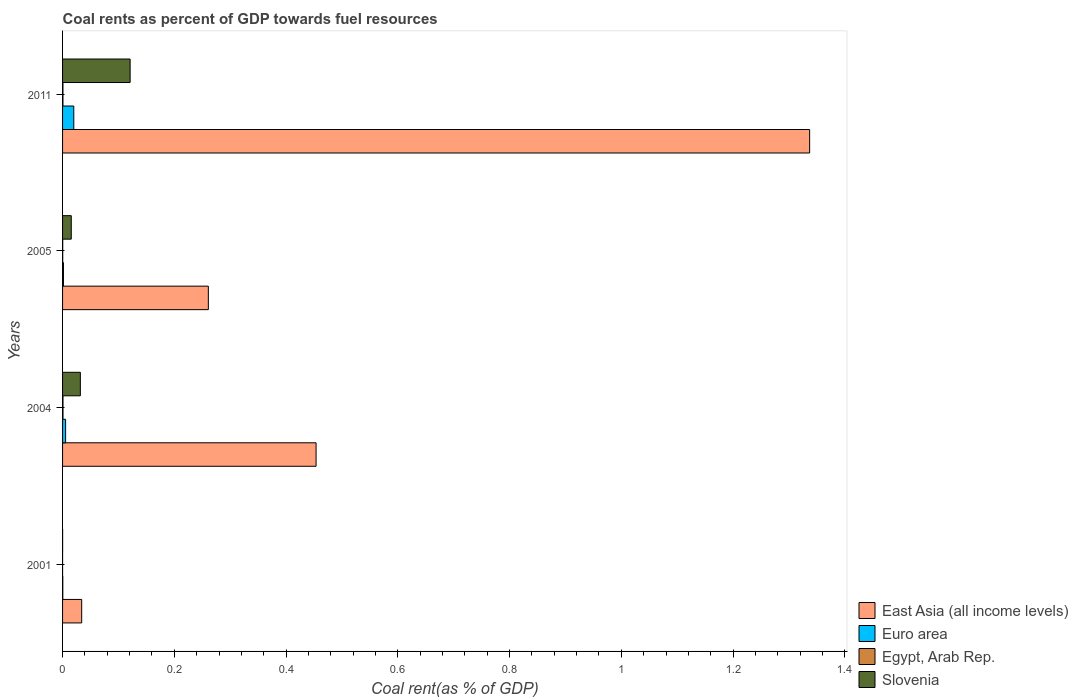Are the number of bars per tick equal to the number of legend labels?
Make the answer very short. Yes. Are the number of bars on each tick of the Y-axis equal?
Your answer should be very brief. Yes. What is the label of the 3rd group of bars from the top?
Keep it short and to the point. 2004. What is the coal rent in Egypt, Arab Rep. in 2001?
Make the answer very short. 1.02739128441411e-6. Across all years, what is the maximum coal rent in Euro area?
Your response must be concise. 0.02. Across all years, what is the minimum coal rent in Euro area?
Your answer should be compact. 0. In which year was the coal rent in Slovenia minimum?
Your answer should be compact. 2001. What is the total coal rent in Slovenia in the graph?
Make the answer very short. 0.17. What is the difference between the coal rent in Euro area in 2004 and that in 2011?
Provide a succinct answer. -0.01. What is the difference between the coal rent in Euro area in 2004 and the coal rent in East Asia (all income levels) in 2001?
Ensure brevity in your answer.  -0.03. What is the average coal rent in Euro area per year?
Give a very brief answer. 0.01. In the year 2004, what is the difference between the coal rent in Euro area and coal rent in Egypt, Arab Rep.?
Keep it short and to the point. 0. In how many years, is the coal rent in East Asia (all income levels) greater than 0.8400000000000001 %?
Make the answer very short. 1. What is the ratio of the coal rent in Euro area in 2004 to that in 2011?
Provide a succinct answer. 0.27. Is the difference between the coal rent in Euro area in 2001 and 2011 greater than the difference between the coal rent in Egypt, Arab Rep. in 2001 and 2011?
Your response must be concise. No. What is the difference between the highest and the second highest coal rent in Euro area?
Keep it short and to the point. 0.01. What is the difference between the highest and the lowest coal rent in East Asia (all income levels)?
Provide a short and direct response. 1.3. In how many years, is the coal rent in Euro area greater than the average coal rent in Euro area taken over all years?
Your response must be concise. 1. Is it the case that in every year, the sum of the coal rent in Slovenia and coal rent in Euro area is greater than the sum of coal rent in Egypt, Arab Rep. and coal rent in East Asia (all income levels)?
Offer a terse response. No. What does the 2nd bar from the top in 2004 represents?
Offer a terse response. Egypt, Arab Rep. What does the 4th bar from the bottom in 2004 represents?
Your response must be concise. Slovenia. Is it the case that in every year, the sum of the coal rent in East Asia (all income levels) and coal rent in Egypt, Arab Rep. is greater than the coal rent in Euro area?
Ensure brevity in your answer.  Yes. How many bars are there?
Offer a very short reply. 16. What is the difference between two consecutive major ticks on the X-axis?
Make the answer very short. 0.2. Are the values on the major ticks of X-axis written in scientific E-notation?
Keep it short and to the point. No. Does the graph contain any zero values?
Keep it short and to the point. No. Does the graph contain grids?
Offer a terse response. No. How many legend labels are there?
Your answer should be compact. 4. How are the legend labels stacked?
Provide a succinct answer. Vertical. What is the title of the graph?
Provide a short and direct response. Coal rents as percent of GDP towards fuel resources. What is the label or title of the X-axis?
Ensure brevity in your answer.  Coal rent(as % of GDP). What is the Coal rent(as % of GDP) of East Asia (all income levels) in 2001?
Make the answer very short. 0.03. What is the Coal rent(as % of GDP) of Euro area in 2001?
Your response must be concise. 0. What is the Coal rent(as % of GDP) of Egypt, Arab Rep. in 2001?
Provide a succinct answer. 1.02739128441411e-6. What is the Coal rent(as % of GDP) of Slovenia in 2001?
Offer a very short reply. 8.55127305686454e-5. What is the Coal rent(as % of GDP) of East Asia (all income levels) in 2004?
Provide a succinct answer. 0.45. What is the Coal rent(as % of GDP) in Euro area in 2004?
Make the answer very short. 0.01. What is the Coal rent(as % of GDP) in Egypt, Arab Rep. in 2004?
Your answer should be very brief. 0. What is the Coal rent(as % of GDP) of Slovenia in 2004?
Provide a succinct answer. 0.03. What is the Coal rent(as % of GDP) in East Asia (all income levels) in 2005?
Keep it short and to the point. 0.26. What is the Coal rent(as % of GDP) in Euro area in 2005?
Offer a very short reply. 0. What is the Coal rent(as % of GDP) in Egypt, Arab Rep. in 2005?
Provide a succinct answer. 0. What is the Coal rent(as % of GDP) of Slovenia in 2005?
Provide a short and direct response. 0.02. What is the Coal rent(as % of GDP) in East Asia (all income levels) in 2011?
Your answer should be compact. 1.34. What is the Coal rent(as % of GDP) of Euro area in 2011?
Your response must be concise. 0.02. What is the Coal rent(as % of GDP) of Egypt, Arab Rep. in 2011?
Give a very brief answer. 0. What is the Coal rent(as % of GDP) of Slovenia in 2011?
Give a very brief answer. 0.12. Across all years, what is the maximum Coal rent(as % of GDP) of East Asia (all income levels)?
Your response must be concise. 1.34. Across all years, what is the maximum Coal rent(as % of GDP) in Euro area?
Offer a very short reply. 0.02. Across all years, what is the maximum Coal rent(as % of GDP) in Egypt, Arab Rep.?
Make the answer very short. 0. Across all years, what is the maximum Coal rent(as % of GDP) of Slovenia?
Keep it short and to the point. 0.12. Across all years, what is the minimum Coal rent(as % of GDP) in East Asia (all income levels)?
Your response must be concise. 0.03. Across all years, what is the minimum Coal rent(as % of GDP) in Euro area?
Offer a very short reply. 0. Across all years, what is the minimum Coal rent(as % of GDP) in Egypt, Arab Rep.?
Make the answer very short. 1.02739128441411e-6. Across all years, what is the minimum Coal rent(as % of GDP) in Slovenia?
Keep it short and to the point. 8.55127305686454e-5. What is the total Coal rent(as % of GDP) of East Asia (all income levels) in the graph?
Your answer should be very brief. 2.09. What is the total Coal rent(as % of GDP) in Euro area in the graph?
Your answer should be very brief. 0.03. What is the total Coal rent(as % of GDP) of Egypt, Arab Rep. in the graph?
Offer a very short reply. 0. What is the total Coal rent(as % of GDP) of Slovenia in the graph?
Your answer should be very brief. 0.17. What is the difference between the Coal rent(as % of GDP) of East Asia (all income levels) in 2001 and that in 2004?
Your answer should be compact. -0.42. What is the difference between the Coal rent(as % of GDP) of Euro area in 2001 and that in 2004?
Provide a short and direct response. -0.01. What is the difference between the Coal rent(as % of GDP) of Egypt, Arab Rep. in 2001 and that in 2004?
Make the answer very short. -0. What is the difference between the Coal rent(as % of GDP) in Slovenia in 2001 and that in 2004?
Your answer should be very brief. -0.03. What is the difference between the Coal rent(as % of GDP) of East Asia (all income levels) in 2001 and that in 2005?
Your answer should be compact. -0.23. What is the difference between the Coal rent(as % of GDP) in Euro area in 2001 and that in 2005?
Offer a very short reply. -0. What is the difference between the Coal rent(as % of GDP) of Egypt, Arab Rep. in 2001 and that in 2005?
Provide a succinct answer. -0. What is the difference between the Coal rent(as % of GDP) of Slovenia in 2001 and that in 2005?
Your answer should be compact. -0.02. What is the difference between the Coal rent(as % of GDP) of East Asia (all income levels) in 2001 and that in 2011?
Make the answer very short. -1.3. What is the difference between the Coal rent(as % of GDP) of Euro area in 2001 and that in 2011?
Make the answer very short. -0.02. What is the difference between the Coal rent(as % of GDP) in Egypt, Arab Rep. in 2001 and that in 2011?
Ensure brevity in your answer.  -0. What is the difference between the Coal rent(as % of GDP) in Slovenia in 2001 and that in 2011?
Your answer should be very brief. -0.12. What is the difference between the Coal rent(as % of GDP) of East Asia (all income levels) in 2004 and that in 2005?
Provide a short and direct response. 0.19. What is the difference between the Coal rent(as % of GDP) of Euro area in 2004 and that in 2005?
Give a very brief answer. 0. What is the difference between the Coal rent(as % of GDP) in Egypt, Arab Rep. in 2004 and that in 2005?
Your answer should be compact. 0. What is the difference between the Coal rent(as % of GDP) of Slovenia in 2004 and that in 2005?
Your answer should be very brief. 0.02. What is the difference between the Coal rent(as % of GDP) in East Asia (all income levels) in 2004 and that in 2011?
Your answer should be very brief. -0.88. What is the difference between the Coal rent(as % of GDP) of Euro area in 2004 and that in 2011?
Your response must be concise. -0.01. What is the difference between the Coal rent(as % of GDP) in Egypt, Arab Rep. in 2004 and that in 2011?
Make the answer very short. 0. What is the difference between the Coal rent(as % of GDP) in Slovenia in 2004 and that in 2011?
Your answer should be very brief. -0.09. What is the difference between the Coal rent(as % of GDP) of East Asia (all income levels) in 2005 and that in 2011?
Keep it short and to the point. -1.08. What is the difference between the Coal rent(as % of GDP) of Euro area in 2005 and that in 2011?
Your response must be concise. -0.02. What is the difference between the Coal rent(as % of GDP) in Egypt, Arab Rep. in 2005 and that in 2011?
Make the answer very short. -0. What is the difference between the Coal rent(as % of GDP) in Slovenia in 2005 and that in 2011?
Offer a terse response. -0.11. What is the difference between the Coal rent(as % of GDP) in East Asia (all income levels) in 2001 and the Coal rent(as % of GDP) in Euro area in 2004?
Your answer should be compact. 0.03. What is the difference between the Coal rent(as % of GDP) in East Asia (all income levels) in 2001 and the Coal rent(as % of GDP) in Egypt, Arab Rep. in 2004?
Ensure brevity in your answer.  0.03. What is the difference between the Coal rent(as % of GDP) of East Asia (all income levels) in 2001 and the Coal rent(as % of GDP) of Slovenia in 2004?
Provide a short and direct response. 0. What is the difference between the Coal rent(as % of GDP) in Euro area in 2001 and the Coal rent(as % of GDP) in Egypt, Arab Rep. in 2004?
Keep it short and to the point. -0. What is the difference between the Coal rent(as % of GDP) of Euro area in 2001 and the Coal rent(as % of GDP) of Slovenia in 2004?
Provide a short and direct response. -0.03. What is the difference between the Coal rent(as % of GDP) in Egypt, Arab Rep. in 2001 and the Coal rent(as % of GDP) in Slovenia in 2004?
Give a very brief answer. -0.03. What is the difference between the Coal rent(as % of GDP) in East Asia (all income levels) in 2001 and the Coal rent(as % of GDP) in Euro area in 2005?
Provide a succinct answer. 0.03. What is the difference between the Coal rent(as % of GDP) in East Asia (all income levels) in 2001 and the Coal rent(as % of GDP) in Egypt, Arab Rep. in 2005?
Your response must be concise. 0.03. What is the difference between the Coal rent(as % of GDP) in East Asia (all income levels) in 2001 and the Coal rent(as % of GDP) in Slovenia in 2005?
Offer a very short reply. 0.02. What is the difference between the Coal rent(as % of GDP) in Euro area in 2001 and the Coal rent(as % of GDP) in Slovenia in 2005?
Offer a very short reply. -0.02. What is the difference between the Coal rent(as % of GDP) of Egypt, Arab Rep. in 2001 and the Coal rent(as % of GDP) of Slovenia in 2005?
Keep it short and to the point. -0.02. What is the difference between the Coal rent(as % of GDP) in East Asia (all income levels) in 2001 and the Coal rent(as % of GDP) in Euro area in 2011?
Your answer should be very brief. 0.01. What is the difference between the Coal rent(as % of GDP) of East Asia (all income levels) in 2001 and the Coal rent(as % of GDP) of Egypt, Arab Rep. in 2011?
Keep it short and to the point. 0.03. What is the difference between the Coal rent(as % of GDP) of East Asia (all income levels) in 2001 and the Coal rent(as % of GDP) of Slovenia in 2011?
Your answer should be very brief. -0.09. What is the difference between the Coal rent(as % of GDP) in Euro area in 2001 and the Coal rent(as % of GDP) in Egypt, Arab Rep. in 2011?
Offer a terse response. -0. What is the difference between the Coal rent(as % of GDP) in Euro area in 2001 and the Coal rent(as % of GDP) in Slovenia in 2011?
Your answer should be very brief. -0.12. What is the difference between the Coal rent(as % of GDP) of Egypt, Arab Rep. in 2001 and the Coal rent(as % of GDP) of Slovenia in 2011?
Offer a very short reply. -0.12. What is the difference between the Coal rent(as % of GDP) of East Asia (all income levels) in 2004 and the Coal rent(as % of GDP) of Euro area in 2005?
Provide a succinct answer. 0.45. What is the difference between the Coal rent(as % of GDP) of East Asia (all income levels) in 2004 and the Coal rent(as % of GDP) of Egypt, Arab Rep. in 2005?
Offer a very short reply. 0.45. What is the difference between the Coal rent(as % of GDP) of East Asia (all income levels) in 2004 and the Coal rent(as % of GDP) of Slovenia in 2005?
Provide a short and direct response. 0.44. What is the difference between the Coal rent(as % of GDP) of Euro area in 2004 and the Coal rent(as % of GDP) of Egypt, Arab Rep. in 2005?
Your answer should be compact. 0.01. What is the difference between the Coal rent(as % of GDP) in Euro area in 2004 and the Coal rent(as % of GDP) in Slovenia in 2005?
Provide a succinct answer. -0.01. What is the difference between the Coal rent(as % of GDP) in Egypt, Arab Rep. in 2004 and the Coal rent(as % of GDP) in Slovenia in 2005?
Your response must be concise. -0.01. What is the difference between the Coal rent(as % of GDP) in East Asia (all income levels) in 2004 and the Coal rent(as % of GDP) in Euro area in 2011?
Make the answer very short. 0.43. What is the difference between the Coal rent(as % of GDP) of East Asia (all income levels) in 2004 and the Coal rent(as % of GDP) of Egypt, Arab Rep. in 2011?
Your answer should be compact. 0.45. What is the difference between the Coal rent(as % of GDP) in East Asia (all income levels) in 2004 and the Coal rent(as % of GDP) in Slovenia in 2011?
Your response must be concise. 0.33. What is the difference between the Coal rent(as % of GDP) of Euro area in 2004 and the Coal rent(as % of GDP) of Egypt, Arab Rep. in 2011?
Your answer should be very brief. 0. What is the difference between the Coal rent(as % of GDP) in Euro area in 2004 and the Coal rent(as % of GDP) in Slovenia in 2011?
Give a very brief answer. -0.12. What is the difference between the Coal rent(as % of GDP) of Egypt, Arab Rep. in 2004 and the Coal rent(as % of GDP) of Slovenia in 2011?
Your response must be concise. -0.12. What is the difference between the Coal rent(as % of GDP) of East Asia (all income levels) in 2005 and the Coal rent(as % of GDP) of Euro area in 2011?
Offer a terse response. 0.24. What is the difference between the Coal rent(as % of GDP) in East Asia (all income levels) in 2005 and the Coal rent(as % of GDP) in Egypt, Arab Rep. in 2011?
Provide a short and direct response. 0.26. What is the difference between the Coal rent(as % of GDP) in East Asia (all income levels) in 2005 and the Coal rent(as % of GDP) in Slovenia in 2011?
Your answer should be very brief. 0.14. What is the difference between the Coal rent(as % of GDP) in Euro area in 2005 and the Coal rent(as % of GDP) in Egypt, Arab Rep. in 2011?
Make the answer very short. 0. What is the difference between the Coal rent(as % of GDP) of Euro area in 2005 and the Coal rent(as % of GDP) of Slovenia in 2011?
Keep it short and to the point. -0.12. What is the difference between the Coal rent(as % of GDP) in Egypt, Arab Rep. in 2005 and the Coal rent(as % of GDP) in Slovenia in 2011?
Provide a succinct answer. -0.12. What is the average Coal rent(as % of GDP) of East Asia (all income levels) per year?
Give a very brief answer. 0.52. What is the average Coal rent(as % of GDP) in Euro area per year?
Keep it short and to the point. 0.01. What is the average Coal rent(as % of GDP) in Slovenia per year?
Give a very brief answer. 0.04. In the year 2001, what is the difference between the Coal rent(as % of GDP) in East Asia (all income levels) and Coal rent(as % of GDP) in Euro area?
Your response must be concise. 0.03. In the year 2001, what is the difference between the Coal rent(as % of GDP) in East Asia (all income levels) and Coal rent(as % of GDP) in Egypt, Arab Rep.?
Your response must be concise. 0.03. In the year 2001, what is the difference between the Coal rent(as % of GDP) in East Asia (all income levels) and Coal rent(as % of GDP) in Slovenia?
Your answer should be compact. 0.03. In the year 2001, what is the difference between the Coal rent(as % of GDP) of Euro area and Coal rent(as % of GDP) of Egypt, Arab Rep.?
Ensure brevity in your answer.  0. In the year 2001, what is the difference between the Coal rent(as % of GDP) in Euro area and Coal rent(as % of GDP) in Slovenia?
Make the answer very short. 0. In the year 2001, what is the difference between the Coal rent(as % of GDP) in Egypt, Arab Rep. and Coal rent(as % of GDP) in Slovenia?
Ensure brevity in your answer.  -0. In the year 2004, what is the difference between the Coal rent(as % of GDP) in East Asia (all income levels) and Coal rent(as % of GDP) in Euro area?
Your response must be concise. 0.45. In the year 2004, what is the difference between the Coal rent(as % of GDP) of East Asia (all income levels) and Coal rent(as % of GDP) of Egypt, Arab Rep.?
Provide a short and direct response. 0.45. In the year 2004, what is the difference between the Coal rent(as % of GDP) in East Asia (all income levels) and Coal rent(as % of GDP) in Slovenia?
Provide a short and direct response. 0.42. In the year 2004, what is the difference between the Coal rent(as % of GDP) in Euro area and Coal rent(as % of GDP) in Egypt, Arab Rep.?
Ensure brevity in your answer.  0. In the year 2004, what is the difference between the Coal rent(as % of GDP) of Euro area and Coal rent(as % of GDP) of Slovenia?
Your answer should be very brief. -0.03. In the year 2004, what is the difference between the Coal rent(as % of GDP) in Egypt, Arab Rep. and Coal rent(as % of GDP) in Slovenia?
Your response must be concise. -0.03. In the year 2005, what is the difference between the Coal rent(as % of GDP) in East Asia (all income levels) and Coal rent(as % of GDP) in Euro area?
Offer a very short reply. 0.26. In the year 2005, what is the difference between the Coal rent(as % of GDP) of East Asia (all income levels) and Coal rent(as % of GDP) of Egypt, Arab Rep.?
Your answer should be compact. 0.26. In the year 2005, what is the difference between the Coal rent(as % of GDP) of East Asia (all income levels) and Coal rent(as % of GDP) of Slovenia?
Provide a short and direct response. 0.25. In the year 2005, what is the difference between the Coal rent(as % of GDP) in Euro area and Coal rent(as % of GDP) in Egypt, Arab Rep.?
Offer a terse response. 0. In the year 2005, what is the difference between the Coal rent(as % of GDP) of Euro area and Coal rent(as % of GDP) of Slovenia?
Give a very brief answer. -0.01. In the year 2005, what is the difference between the Coal rent(as % of GDP) in Egypt, Arab Rep. and Coal rent(as % of GDP) in Slovenia?
Offer a terse response. -0.02. In the year 2011, what is the difference between the Coal rent(as % of GDP) in East Asia (all income levels) and Coal rent(as % of GDP) in Euro area?
Provide a short and direct response. 1.32. In the year 2011, what is the difference between the Coal rent(as % of GDP) of East Asia (all income levels) and Coal rent(as % of GDP) of Egypt, Arab Rep.?
Ensure brevity in your answer.  1.34. In the year 2011, what is the difference between the Coal rent(as % of GDP) of East Asia (all income levels) and Coal rent(as % of GDP) of Slovenia?
Your answer should be compact. 1.22. In the year 2011, what is the difference between the Coal rent(as % of GDP) of Euro area and Coal rent(as % of GDP) of Egypt, Arab Rep.?
Your answer should be compact. 0.02. In the year 2011, what is the difference between the Coal rent(as % of GDP) in Euro area and Coal rent(as % of GDP) in Slovenia?
Ensure brevity in your answer.  -0.1. In the year 2011, what is the difference between the Coal rent(as % of GDP) in Egypt, Arab Rep. and Coal rent(as % of GDP) in Slovenia?
Make the answer very short. -0.12. What is the ratio of the Coal rent(as % of GDP) in East Asia (all income levels) in 2001 to that in 2004?
Provide a succinct answer. 0.08. What is the ratio of the Coal rent(as % of GDP) in Euro area in 2001 to that in 2004?
Provide a short and direct response. 0.08. What is the ratio of the Coal rent(as % of GDP) in Egypt, Arab Rep. in 2001 to that in 2004?
Offer a very short reply. 0. What is the ratio of the Coal rent(as % of GDP) of Slovenia in 2001 to that in 2004?
Your answer should be very brief. 0. What is the ratio of the Coal rent(as % of GDP) in East Asia (all income levels) in 2001 to that in 2005?
Ensure brevity in your answer.  0.13. What is the ratio of the Coal rent(as % of GDP) of Euro area in 2001 to that in 2005?
Give a very brief answer. 0.27. What is the ratio of the Coal rent(as % of GDP) of Egypt, Arab Rep. in 2001 to that in 2005?
Keep it short and to the point. 0. What is the ratio of the Coal rent(as % of GDP) of Slovenia in 2001 to that in 2005?
Make the answer very short. 0.01. What is the ratio of the Coal rent(as % of GDP) of East Asia (all income levels) in 2001 to that in 2011?
Ensure brevity in your answer.  0.03. What is the ratio of the Coal rent(as % of GDP) of Euro area in 2001 to that in 2011?
Ensure brevity in your answer.  0.02. What is the ratio of the Coal rent(as % of GDP) of Egypt, Arab Rep. in 2001 to that in 2011?
Your answer should be compact. 0. What is the ratio of the Coal rent(as % of GDP) of Slovenia in 2001 to that in 2011?
Offer a very short reply. 0. What is the ratio of the Coal rent(as % of GDP) in East Asia (all income levels) in 2004 to that in 2005?
Your answer should be compact. 1.74. What is the ratio of the Coal rent(as % of GDP) of Euro area in 2004 to that in 2005?
Your answer should be very brief. 3.44. What is the ratio of the Coal rent(as % of GDP) in Egypt, Arab Rep. in 2004 to that in 2005?
Offer a very short reply. 2.83. What is the ratio of the Coal rent(as % of GDP) in Slovenia in 2004 to that in 2005?
Your answer should be very brief. 2.04. What is the ratio of the Coal rent(as % of GDP) of East Asia (all income levels) in 2004 to that in 2011?
Provide a succinct answer. 0.34. What is the ratio of the Coal rent(as % of GDP) in Euro area in 2004 to that in 2011?
Offer a terse response. 0.27. What is the ratio of the Coal rent(as % of GDP) of Egypt, Arab Rep. in 2004 to that in 2011?
Ensure brevity in your answer.  1.13. What is the ratio of the Coal rent(as % of GDP) of Slovenia in 2004 to that in 2011?
Make the answer very short. 0.26. What is the ratio of the Coal rent(as % of GDP) of East Asia (all income levels) in 2005 to that in 2011?
Give a very brief answer. 0.2. What is the ratio of the Coal rent(as % of GDP) of Euro area in 2005 to that in 2011?
Provide a short and direct response. 0.08. What is the ratio of the Coal rent(as % of GDP) of Egypt, Arab Rep. in 2005 to that in 2011?
Offer a very short reply. 0.4. What is the ratio of the Coal rent(as % of GDP) in Slovenia in 2005 to that in 2011?
Your answer should be very brief. 0.13. What is the difference between the highest and the second highest Coal rent(as % of GDP) in East Asia (all income levels)?
Your answer should be compact. 0.88. What is the difference between the highest and the second highest Coal rent(as % of GDP) of Euro area?
Your answer should be very brief. 0.01. What is the difference between the highest and the second highest Coal rent(as % of GDP) of Egypt, Arab Rep.?
Your response must be concise. 0. What is the difference between the highest and the second highest Coal rent(as % of GDP) of Slovenia?
Provide a short and direct response. 0.09. What is the difference between the highest and the lowest Coal rent(as % of GDP) of East Asia (all income levels)?
Ensure brevity in your answer.  1.3. What is the difference between the highest and the lowest Coal rent(as % of GDP) of Euro area?
Make the answer very short. 0.02. What is the difference between the highest and the lowest Coal rent(as % of GDP) of Egypt, Arab Rep.?
Offer a very short reply. 0. What is the difference between the highest and the lowest Coal rent(as % of GDP) in Slovenia?
Offer a very short reply. 0.12. 